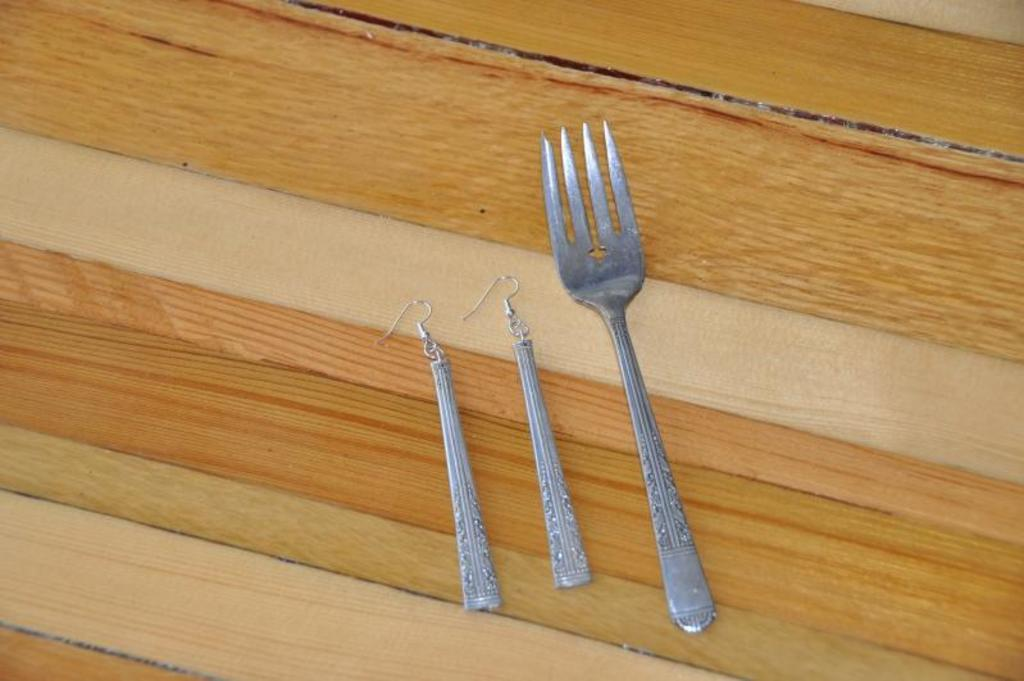What utensil is present in the image? There is a fork in the image. What type of accessory is also visible in the image? There are earrings in the image. Where are the fork and earrings located? Both the fork and earrings are on a table. What type of wing is visible on the birthday cake in the image? There is no birthday cake or wing present in the image; it only features a fork and earrings on a table. 